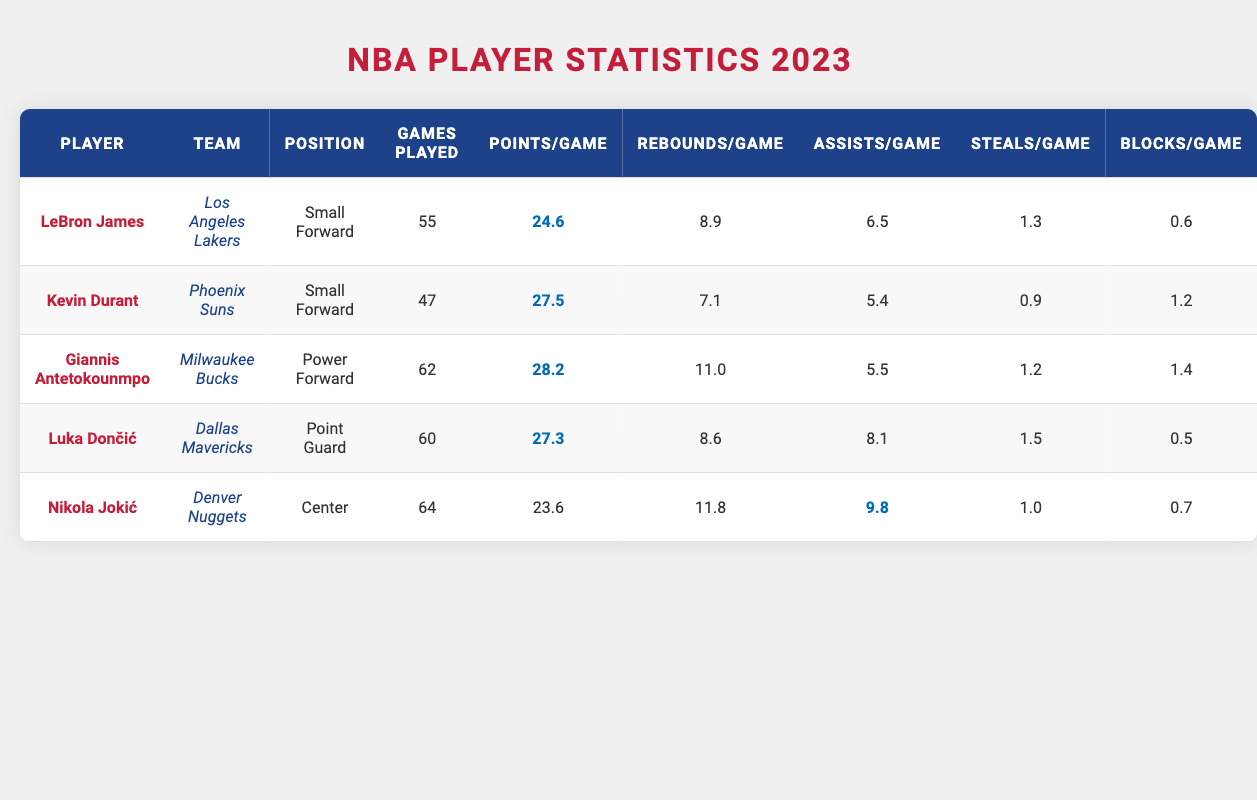What is the average points per game scored by all players in the table? To find the average points per game, first sum the points per game values: 24.6 + 27.5 + 28.2 + 27.3 + 23.6 = 131.2. There are 5 players, so the average is 131.2 divided by 5, which equals 26.24.
Answer: 26.24 Which player has the highest rebounds per game? By looking at the rebounds per game column, Giannis Antetokounmpo has the highest value at 11.0 rebounds per game.
Answer: Giannis Antetokounmpo How many players played more than 60 games? Reviewing the games played column, both Giannis Antetokounmpo (62) and Nikola Jokić (64) played more than 60 games. This gives a total of 2 players.
Answer: 2 True or False: Kevin Durant has more points per game than LeBron James. Comparing the points per game for both players, Kevin Durant has 27.5 while LeBron James has 24.6. Since 27.5 is more than 24.6, the statement is true.
Answer: True What is the total number of assists made by all players? To find the total assists, sum the assists per game values: 6.5 + 5.4 + 5.5 + 8.1 + 9.8 = 35.3.
Answer: 35.3 